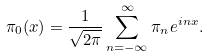<formula> <loc_0><loc_0><loc_500><loc_500>\pi _ { 0 } ( x ) = \frac { 1 } { \sqrt { 2 \pi } } \sum _ { n = - \infty } ^ { \infty } \pi _ { n } e ^ { i n x } .</formula> 